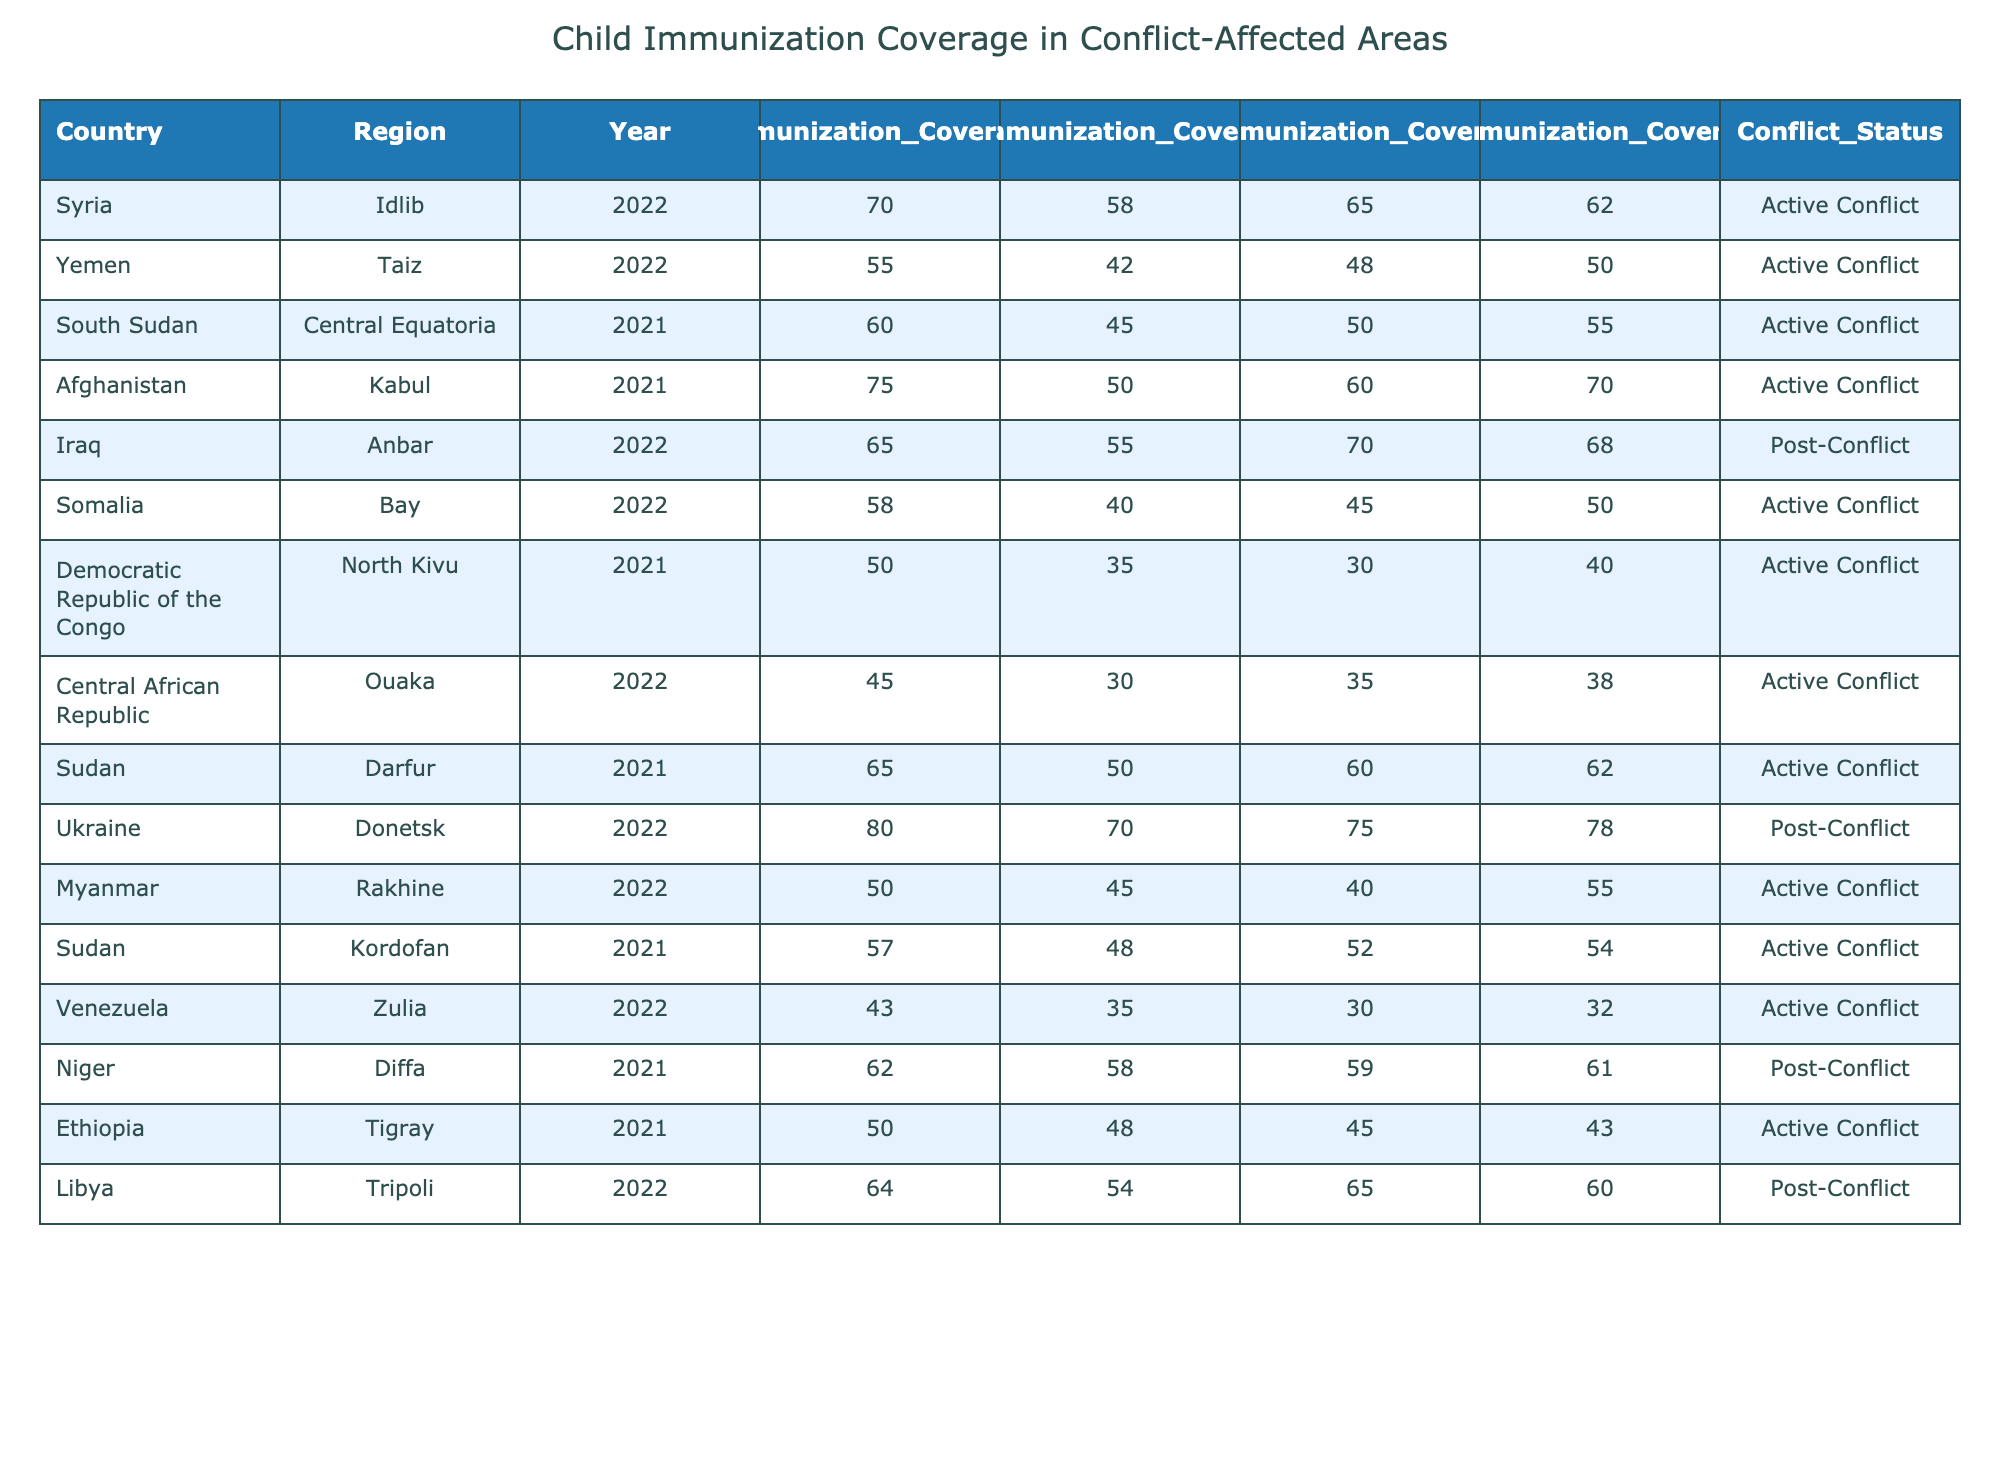What is the immunization coverage rate for DTP1 in Syria's Idlib region in 2022? The table shows that the immunization coverage rate for DTP1 in Syria's Idlib region in 2022 is 70%.
Answer: 70% Which country has the lowest immunization coverage for the measles-rubella vaccine (MR) in 2022? By inspecting the table, we see that Venezuela has the lowest measles-rubella (MR) immunization coverage rate at 35%.
Answer: Venezuela What is the difference in OpV coverage between Afghanistan and Somalia in 2021 and 2022? Afghanistan's OpV coverage in 2021 is 70%, and Somalia's OpV coverage in 2022 is 50%. The difference is 70 - 50 = 20%.
Answer: 20% What is the average child immunization coverage for DTP1 in active conflict regions based on the data provided? We sum the DTP1 coverage rates for countries in active conflict (70, 55, 60, 75, 58, 50, 45, 65, 57, and 62), which totals to  70 + 55 + 60 + 75 + 58 + 50 + 45 + 65 + 57 + 62 =  157  + 62 =  131 + 70 = 67. We'll divide by 10, since there are 10 regions:  67/10= 62.
Answer: 62% Is the child immunization coverage for DTP1 in the Central African Republic higher than that in Yemen? The DTP1 coverage for the Central African Republic is 45%, while Yemen's is 55%. Since 45% is not higher than 55%, the statement is false.
Answer: No Which conflict status has the highest average coverage for the pneumococcal vaccine (PCV) from the data? The average PCV coverage for each conflict status is calculated: Active Conflict (65 + 48 + 50 + 60 + 45 + 30 + 35 + 52) = 485/8 = 60.625%, and for Post-Conflict (70 + 75 + 59 + 65) = 269/4 = 67.25%. Post-Conflict has the highest average at 67.25%.
Answer: Post-Conflict What are the immunization coverage rates for all vaccines in Iraq's Anbar region for 2022? The table indicates that Iraq's Anbar region has the following immunization coverage rates for 2022: DTP1: 65%, MR: 55%, PCV: 70%, and OpV: 68%.
Answer: DTP1: 65%, MR: 55%, PCV: 70%, OpV: 68% How does PCV coverage in the active conflict region of South Sudan compare to that in the post-conflict region of Ukraine? The PCV coverage in South Sudan (50%) is less than that of Ukraine (75%). Therefore, South Sudan has lower PCV coverage than Ukraine.
Answer: South Sudan has lower PCV coverage Which country in the data has a conflict status of "Post-Conflict" and what is its DTP1 coverage? The countries with Post-Conflict status are Iraq and Niger, with DTP1 coverage rates of 65% and 62%, respectively.
Answer: Iraq: 65%, Niger: 62% Are there any active conflict areas with a higher rate of measles-rubella vaccine (MR) than 55%? Checking the active conflict areas, only Afghanistan (50%), Yemen (42%), Somalia (40%), Democratic Republic of the Congo (35%), Central African Republic (30%), and Tigray (48%) have rates lower than 55%. Only Syria and South Sudan have rates of 58% and 45% respectively. Hence, there are two areas.
Answer: Yes, there are two areas Which active conflict region has the highest child immunization coverage for OpV? In the active conflict regions, Afghanistan has the highest OpV coverage at 70%. Other regions have lower rates.
Answer: Afghanistan 